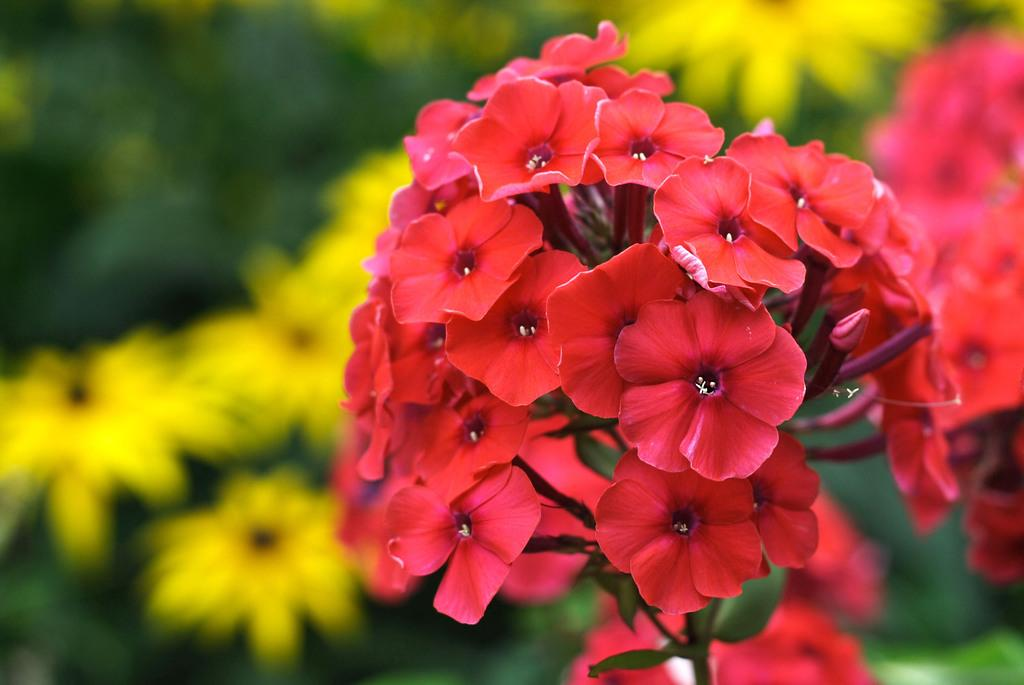What is the main subject of the image? The main subject of the image is flowers. Can you describe the color of the flowers in the image? The flowers in the image are red in color. How would you describe the background of the image? The background of the image is blurred. Are there any other flowers visible in the image besides the ones in the center? Yes, there are additional flowers visible in the background. How does the expert feel about the boat in the image? There is no expert or boat present in the image, so it is not possible to answer that question. 